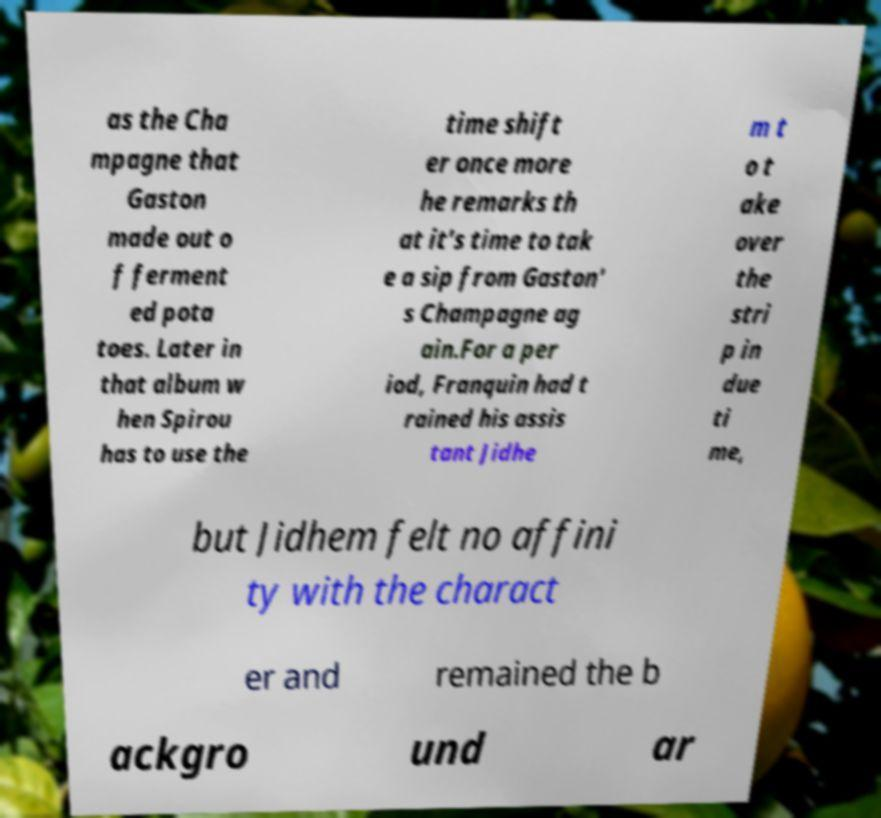For documentation purposes, I need the text within this image transcribed. Could you provide that? as the Cha mpagne that Gaston made out o f ferment ed pota toes. Later in that album w hen Spirou has to use the time shift er once more he remarks th at it's time to tak e a sip from Gaston' s Champagne ag ain.For a per iod, Franquin had t rained his assis tant Jidhe m t o t ake over the stri p in due ti me, but Jidhem felt no affini ty with the charact er and remained the b ackgro und ar 